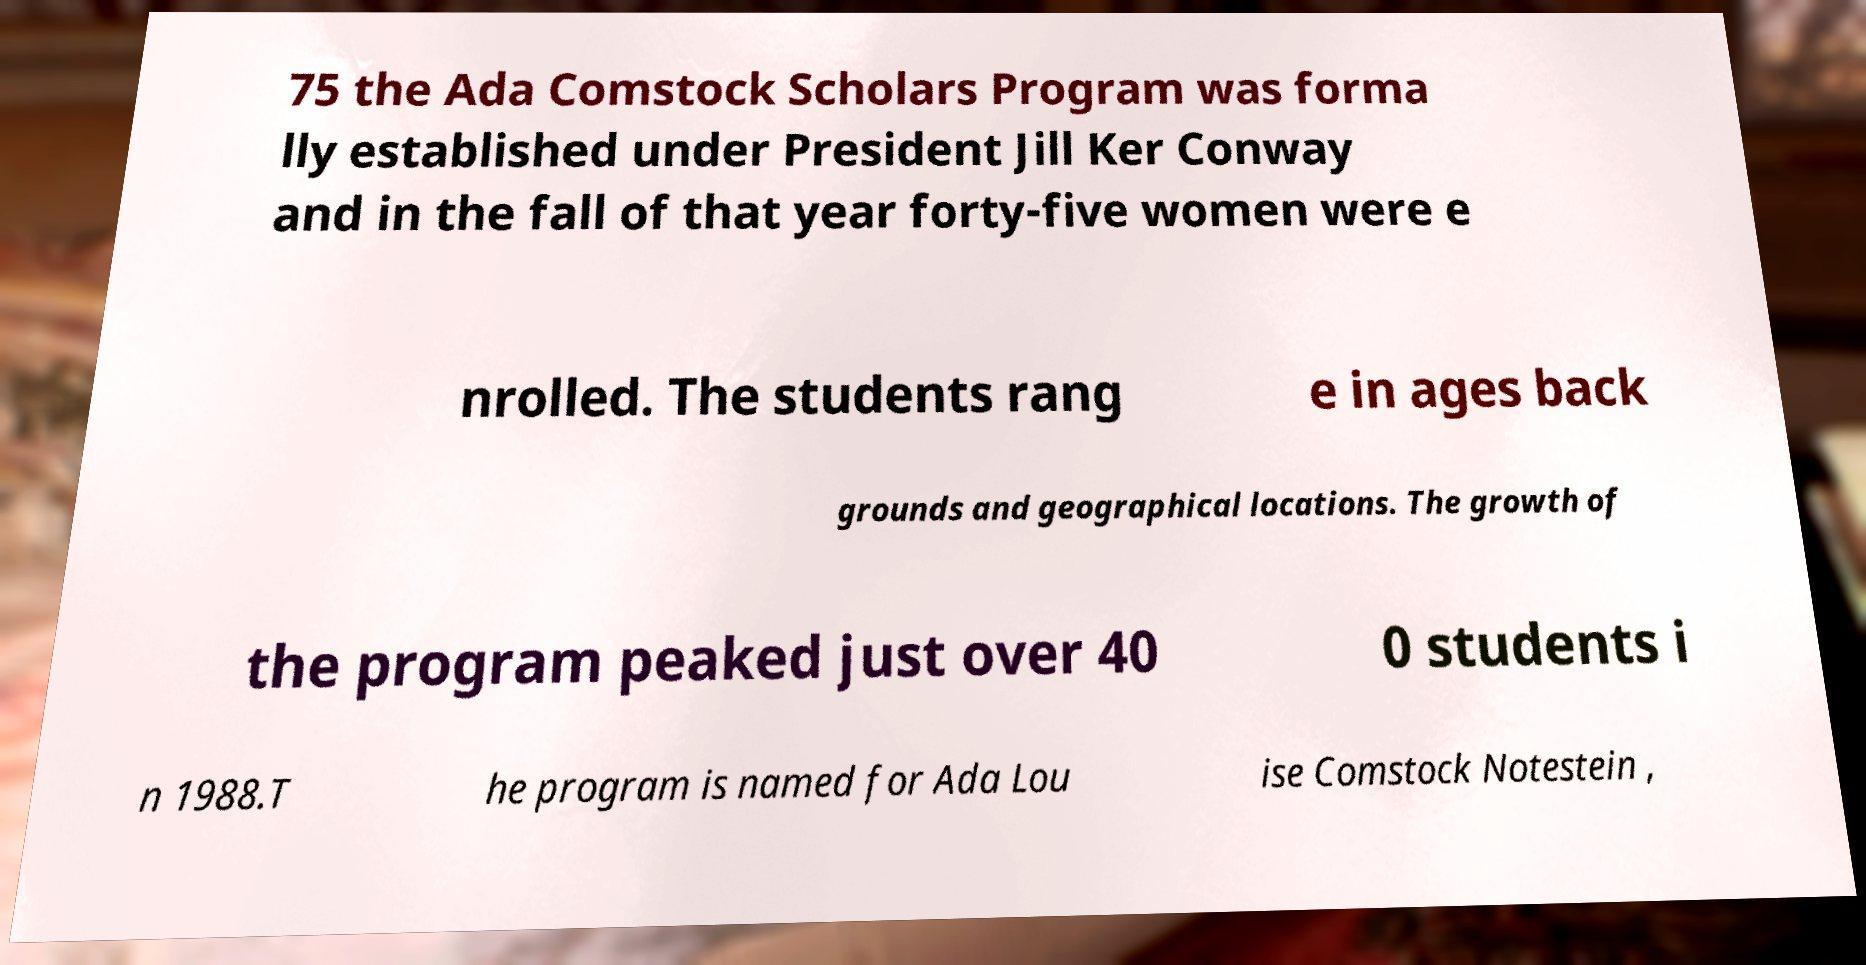Could you extract and type out the text from this image? 75 the Ada Comstock Scholars Program was forma lly established under President Jill Ker Conway and in the fall of that year forty-five women were e nrolled. The students rang e in ages back grounds and geographical locations. The growth of the program peaked just over 40 0 students i n 1988.T he program is named for Ada Lou ise Comstock Notestein , 